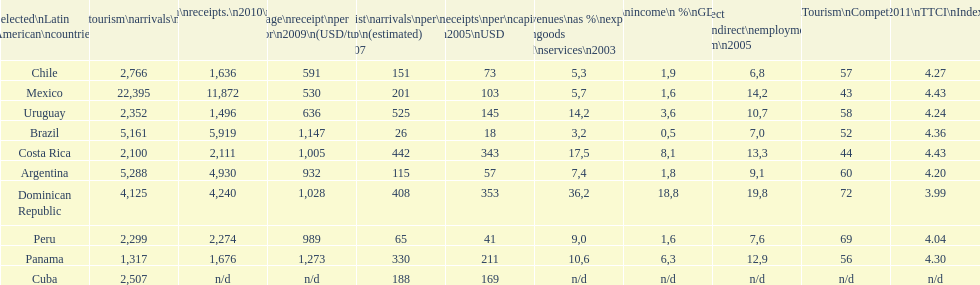In 2010, which country in latin america received the highest number of tourists? Mexico. 